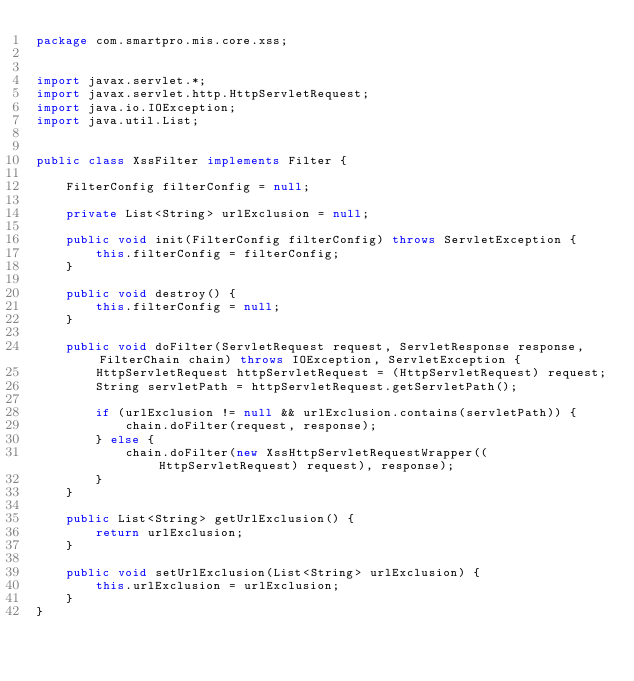<code> <loc_0><loc_0><loc_500><loc_500><_Java_>package com.smartpro.mis.core.xss;


import javax.servlet.*;
import javax.servlet.http.HttpServletRequest;
import java.io.IOException;
import java.util.List;


public class XssFilter implements Filter {

    FilterConfig filterConfig = null;

    private List<String> urlExclusion = null;

    public void init(FilterConfig filterConfig) throws ServletException {
        this.filterConfig = filterConfig;
    }

    public void destroy() {
        this.filterConfig = null;
    }

    public void doFilter(ServletRequest request, ServletResponse response, FilterChain chain) throws IOException, ServletException {
        HttpServletRequest httpServletRequest = (HttpServletRequest) request;
        String servletPath = httpServletRequest.getServletPath();

        if (urlExclusion != null && urlExclusion.contains(servletPath)) {
            chain.doFilter(request, response);
        } else {
            chain.doFilter(new XssHttpServletRequestWrapper((HttpServletRequest) request), response);
        }
    }

    public List<String> getUrlExclusion() {
        return urlExclusion;
    }

    public void setUrlExclusion(List<String> urlExclusion) {
        this.urlExclusion = urlExclusion;
    }
}</code> 